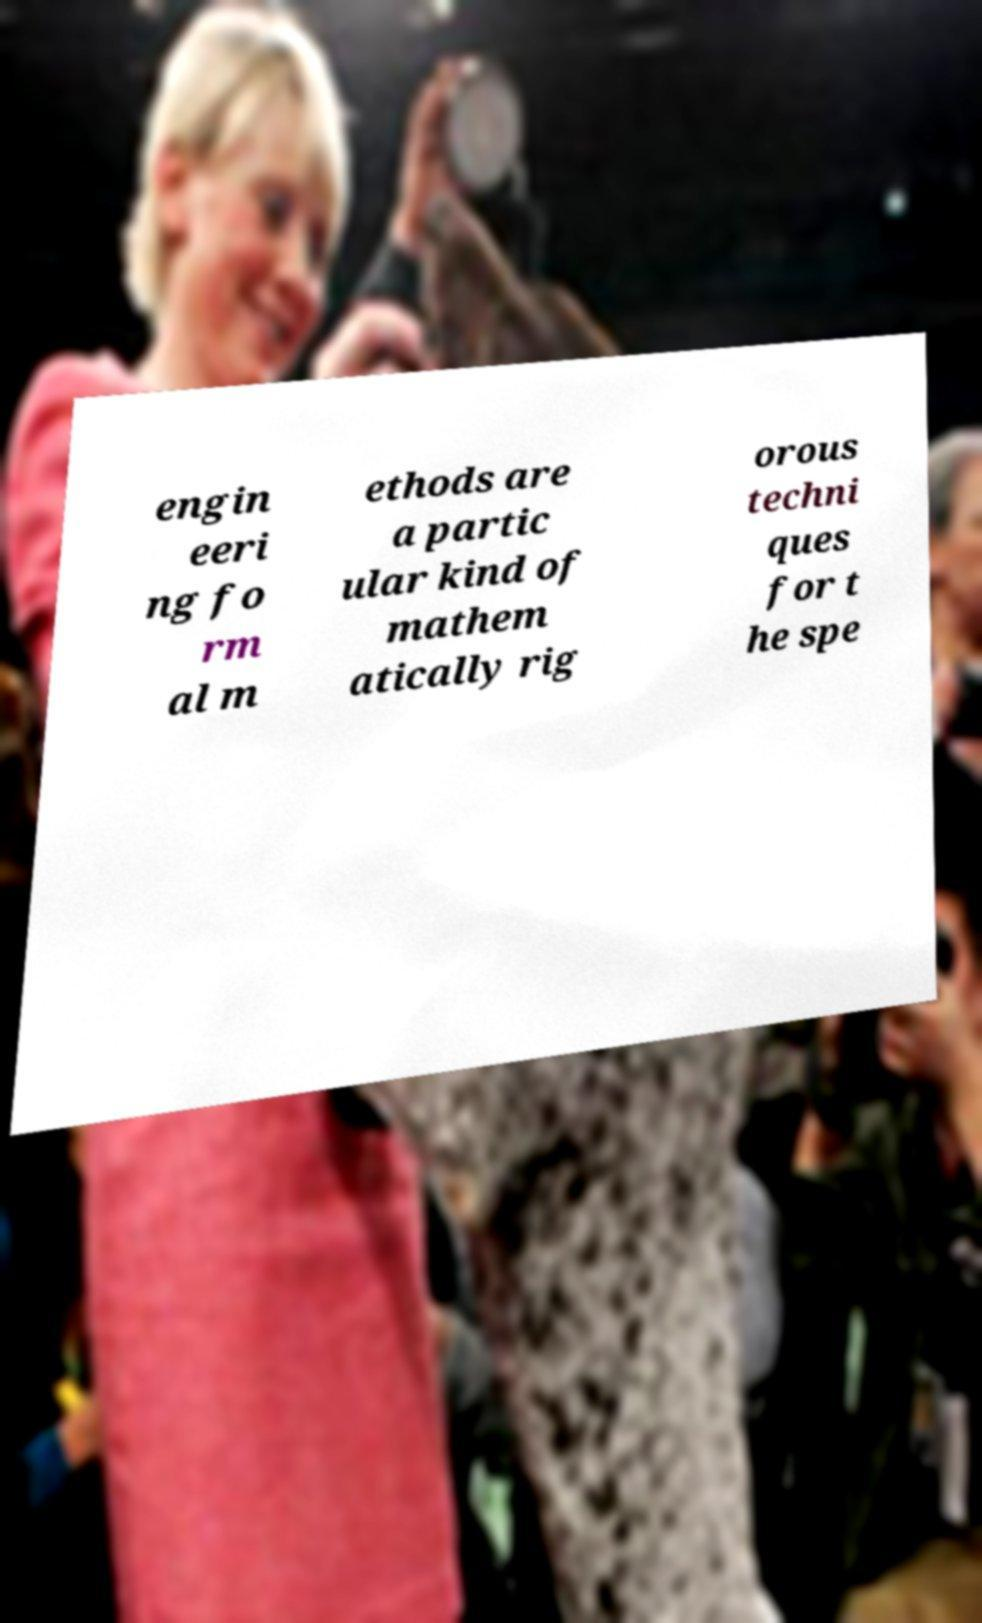What messages or text are displayed in this image? I need them in a readable, typed format. engin eeri ng fo rm al m ethods are a partic ular kind of mathem atically rig orous techni ques for t he spe 